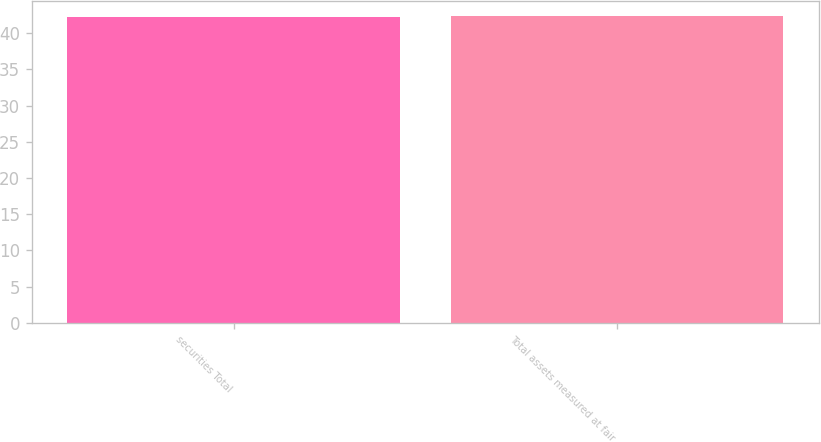Convert chart to OTSL. <chart><loc_0><loc_0><loc_500><loc_500><bar_chart><fcel>securities Total<fcel>Total assets measured at fair<nl><fcel>42.3<fcel>42.4<nl></chart> 